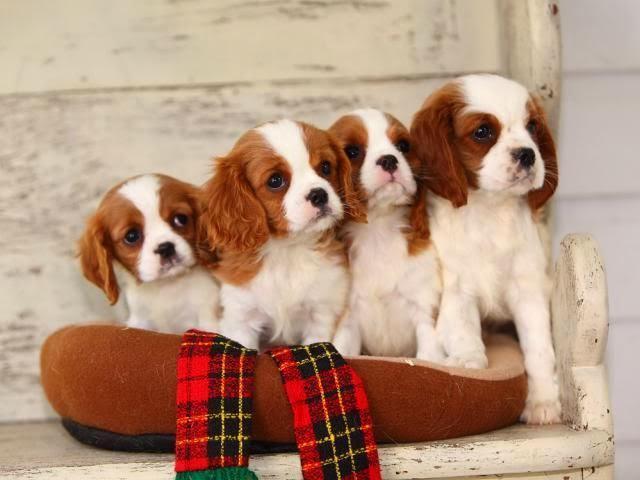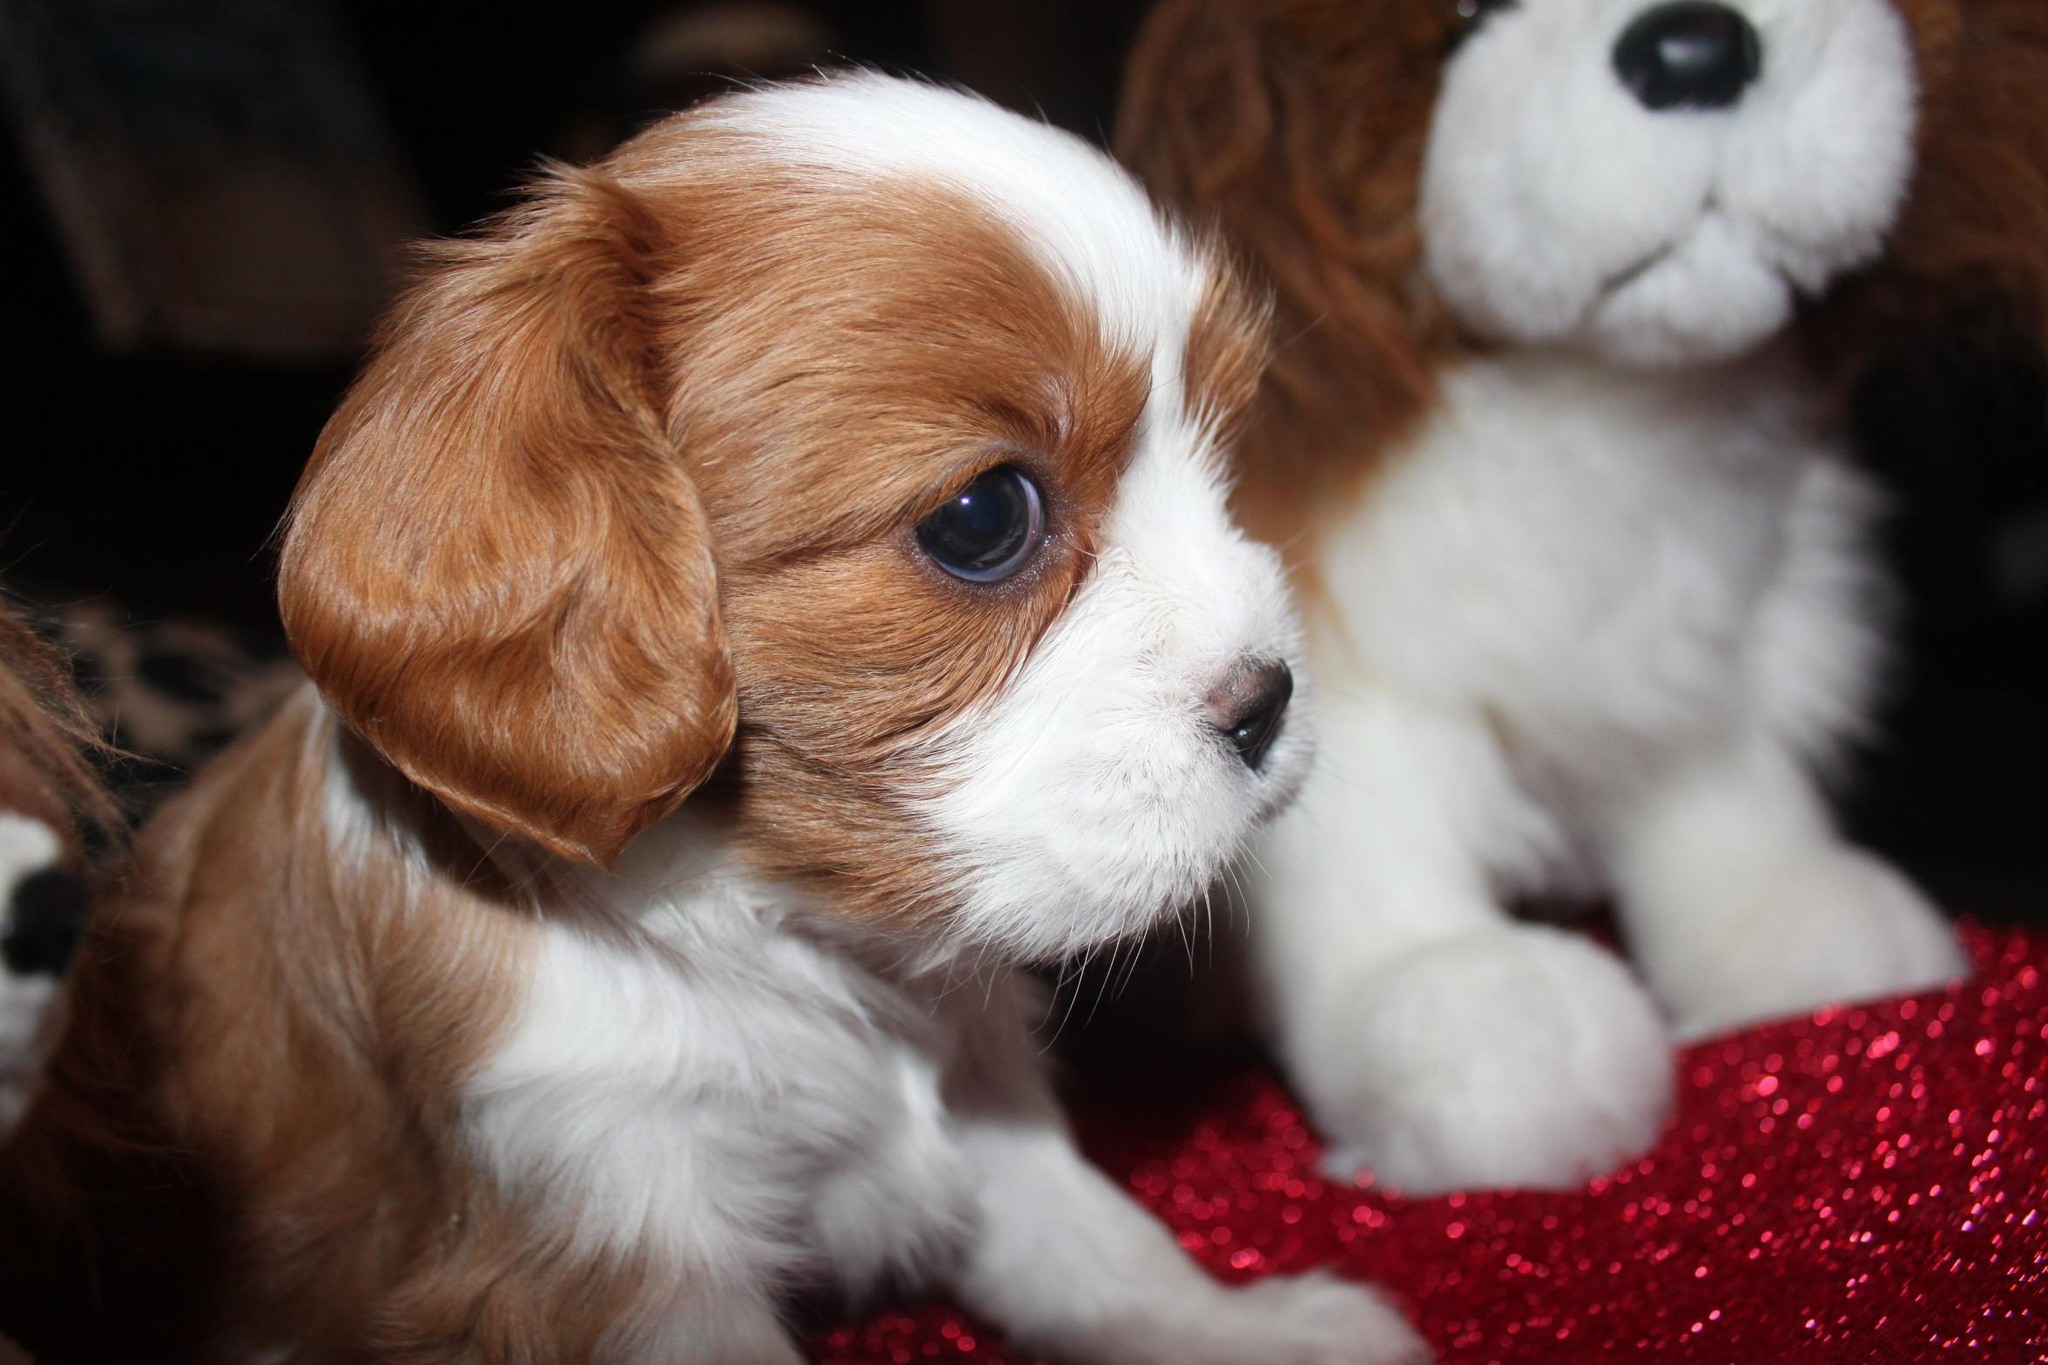The first image is the image on the left, the second image is the image on the right. Considering the images on both sides, is "The right image shows an adult, brown and white colored cocker spaniel mom with multiple puppies nursing" valid? Answer yes or no. No. The first image is the image on the left, the second image is the image on the right. For the images displayed, is the sentence "Multiple white-and-orange puppies pose upright and side-by-side in some type of container." factually correct? Answer yes or no. Yes. 